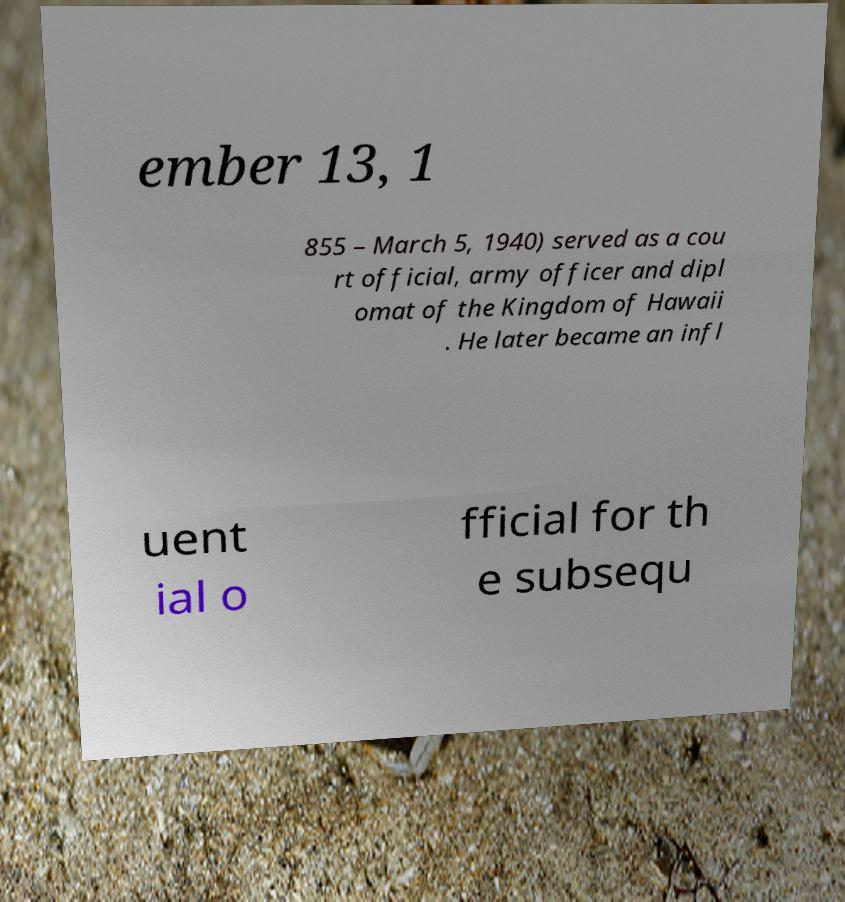Can you accurately transcribe the text from the provided image for me? ember 13, 1 855 – March 5, 1940) served as a cou rt official, army officer and dipl omat of the Kingdom of Hawaii . He later became an infl uent ial o fficial for th e subsequ 